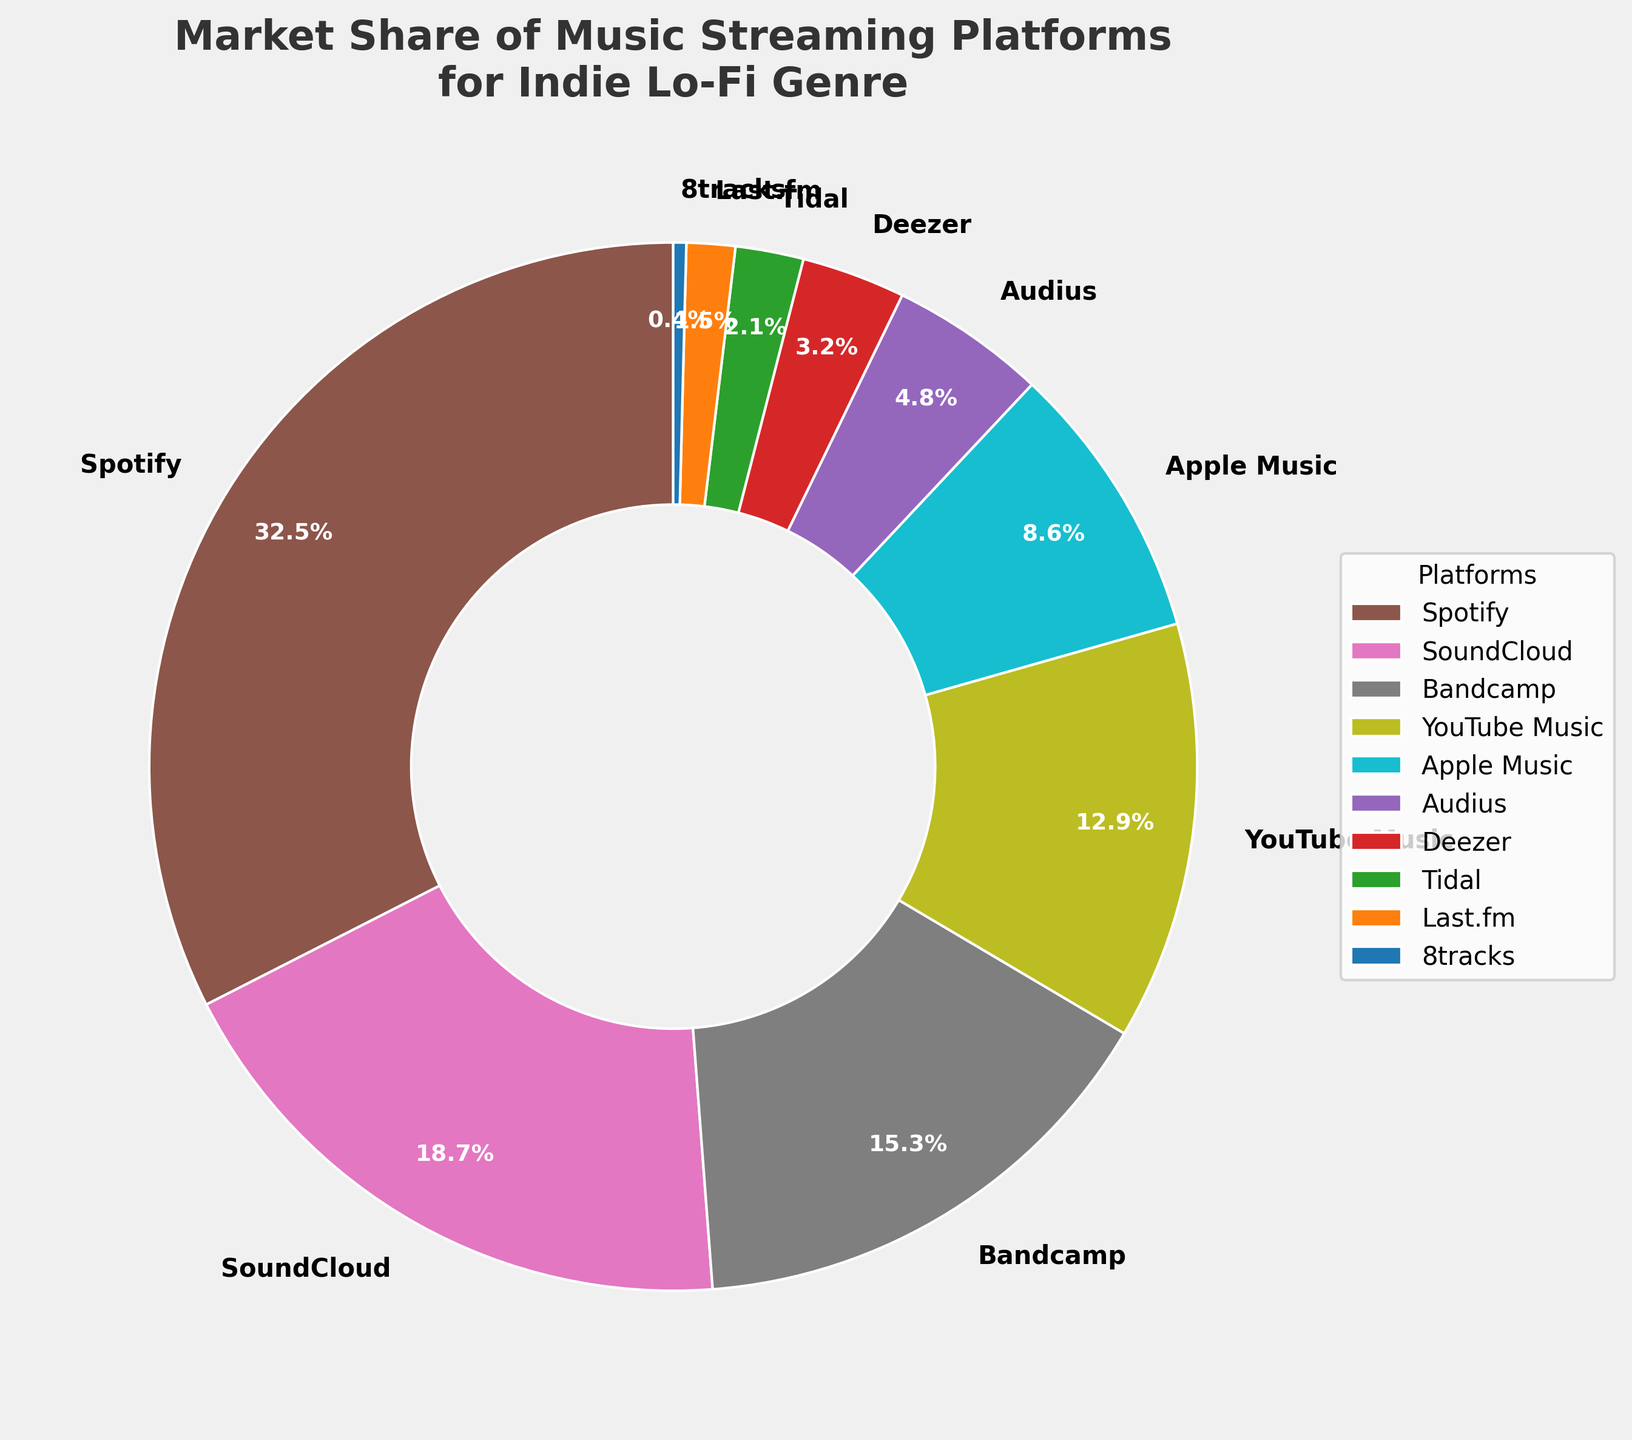What's the market share of Spotify? The pie chart shows the market share of various music streaming platforms. Look for the segment labeled "Spotify" and check the percentage shown.
Answer: 32.5% Which platform has the smallest market share? Review the pie chart and identify the segment with the smallest percentage. It is labeled "8tracks."
Answer: 8tracks How much more market share does Spotify have compared to Apple Music? Find the market shares for Spotify (32.5%) and Apple Music (8.6%) from the pie chart, and calculate the difference between them: 32.5% - 8.6%.
Answer: 23.9% What is the combined market share of SoundCloud and Bandcamp? Look for the segments labeled "SoundCloud" (18.7%) and "Bandcamp" (15.3%) on the pie chart, then add these percentages together: 18.7% + 15.3%.
Answer: 34.0% Which platform has a larger market share: Tidal or Last.fm? Identify the market shares for Tidal (2.1%) and Last.fm (1.5%) from the pie chart. Compare these two values to see which is higher.
Answer: Tidal What is the difference in market share between YouTube Music and Deezer? Find the market shares of YouTube Music (12.9%) and Deezer (3.2%) on the pie chart, and subtract the smaller from the larger: 12.9% - 3.2%.
Answer: 9.7% Which platform with less than a 5% market share has the highest percentage? Review the pie chart and focus on platforms with less than 5% market share (Audius, Deezer, Tidal, Last.fm, 8tracks). Audius has the highest percentage among them.
Answer: Audius What is the total market share of platforms with more than 15% but less than 35% share? Identify the platforms within this range: Spotify (32.5%), SoundCloud (18.7%), and Bandcamp (15.3%). Add their shares: 32.5% + 18.7% + 15.3%.
Answer: 66.5% What color is used to represent Apple Music in the chart? Observe the pie chart and locate the segment labeled "Apple Music." Note the color used to represent this segment.
Answer: Light blue What is the average market share of the three smallest platforms? Identify the market shares of the three smallest platforms: Last.fm (1.5%), Tidal (2.1%), and 8tracks (0.4%). Calculate the average: (1.5% + 2.1% + 0.4%) / 3.
Answer: 1.33% 